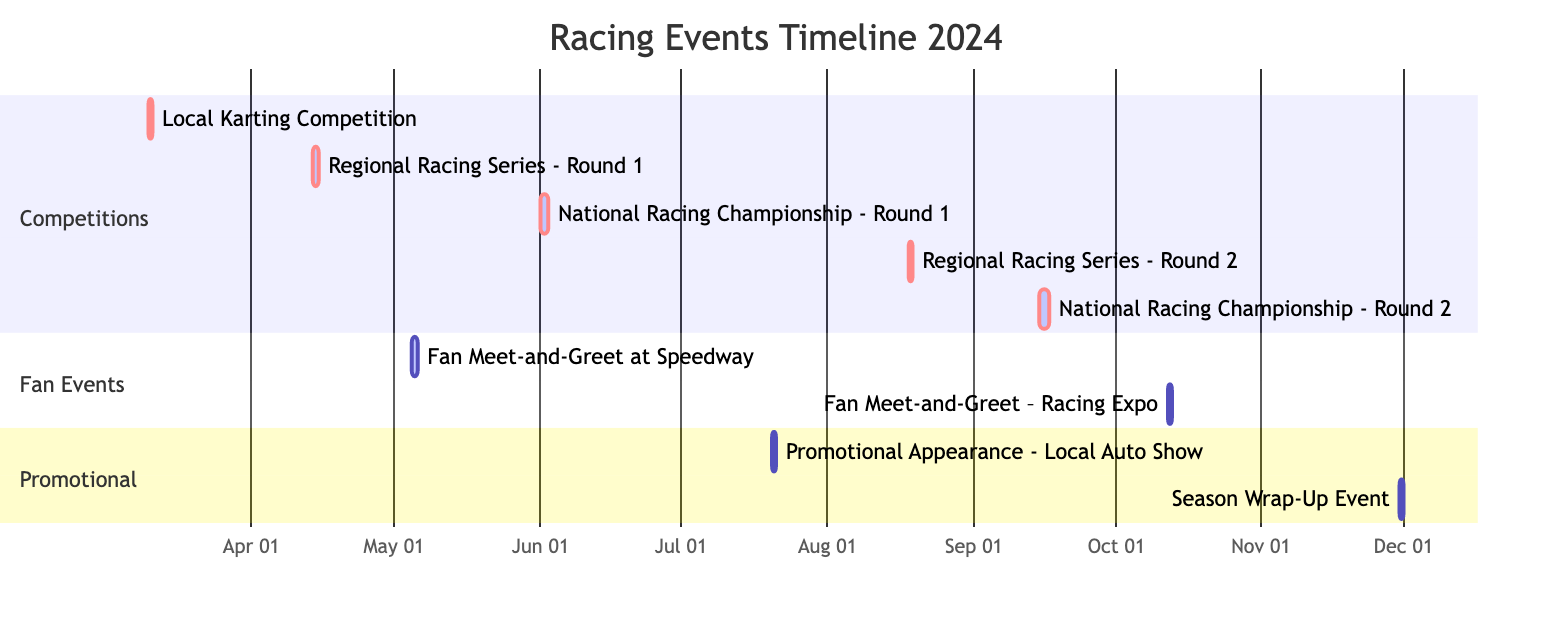What is the date of the Local Karting Competition? The Local Karting Competition starts and ends on March 10, 2024, as indicated in the Gantt chart.
Answer: March 10, 2024 How many events are scheduled for June 2024? According to the diagram, there are two events in June: National Racing Championship - Round 1 (June 1-2) and the Fan Meet-and-Greet (June 5).
Answer: 2 What is the last event scheduled in 2024? The Season Wrap-Up Event is shown on November 30, 2024, which is the final event listed on the Gantt chart.
Answer: Season Wrap-Up Event Which event lasts for two days? The National Racing Championship - Round 1 on June 1-2 and National Racing Championship - Round 2 on September 15-16 both have a duration of two days as seen in their timeline.
Answer: National Racing Championship - Round 1 and National Racing Championship - Round 2 What type of events are scheduled in the month of July? The diagram specifies that there is one promotional appearance scheduled in July, which is the Promotional Appearance at the Local Auto Show on July 20, 2024.
Answer: Promotional Appearance Which competition occurs immediately after the Regional Racing Series - Round 1? The next competition displayed in the timeline after the Regional Racing Series - Round 1 on April 14 is the National Racing Championship - Round 1 on June 1.
Answer: National Racing Championship - Round 1 What is the earliest event listed in the timeline? The earliest event in the Gantt chart is the Local Karting Competition that takes place on March 10, 2024.
Answer: Local Karting Competition How many fan meet-and-greet events are planned for 2024? There are two fan meet-and-greet events shown in the Gantt chart; one on May 5 and another on October 12.
Answer: 2 Which promotional event is scheduled for July? The only promotional event scheduled for July is the Promotional Appearance at the Local Auto Show on July 20, 2024.
Answer: Promotional Appearance - Local Auto Show 